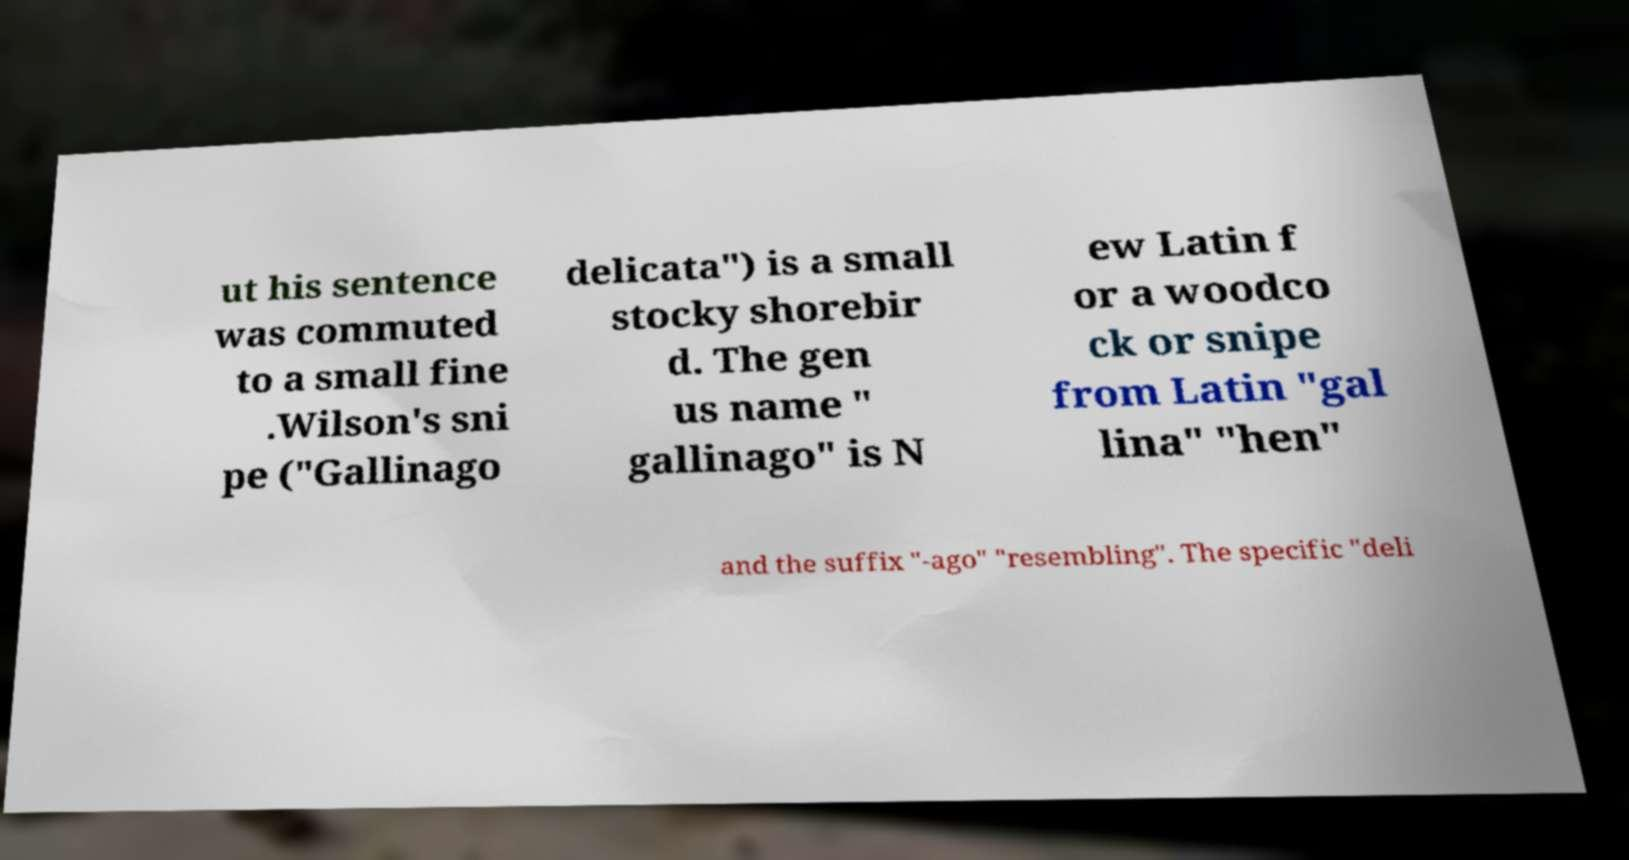Can you accurately transcribe the text from the provided image for me? ut his sentence was commuted to a small fine .Wilson's sni pe ("Gallinago delicata") is a small stocky shorebir d. The gen us name " gallinago" is N ew Latin f or a woodco ck or snipe from Latin "gal lina" "hen" and the suffix "-ago" "resembling". The specific "deli 